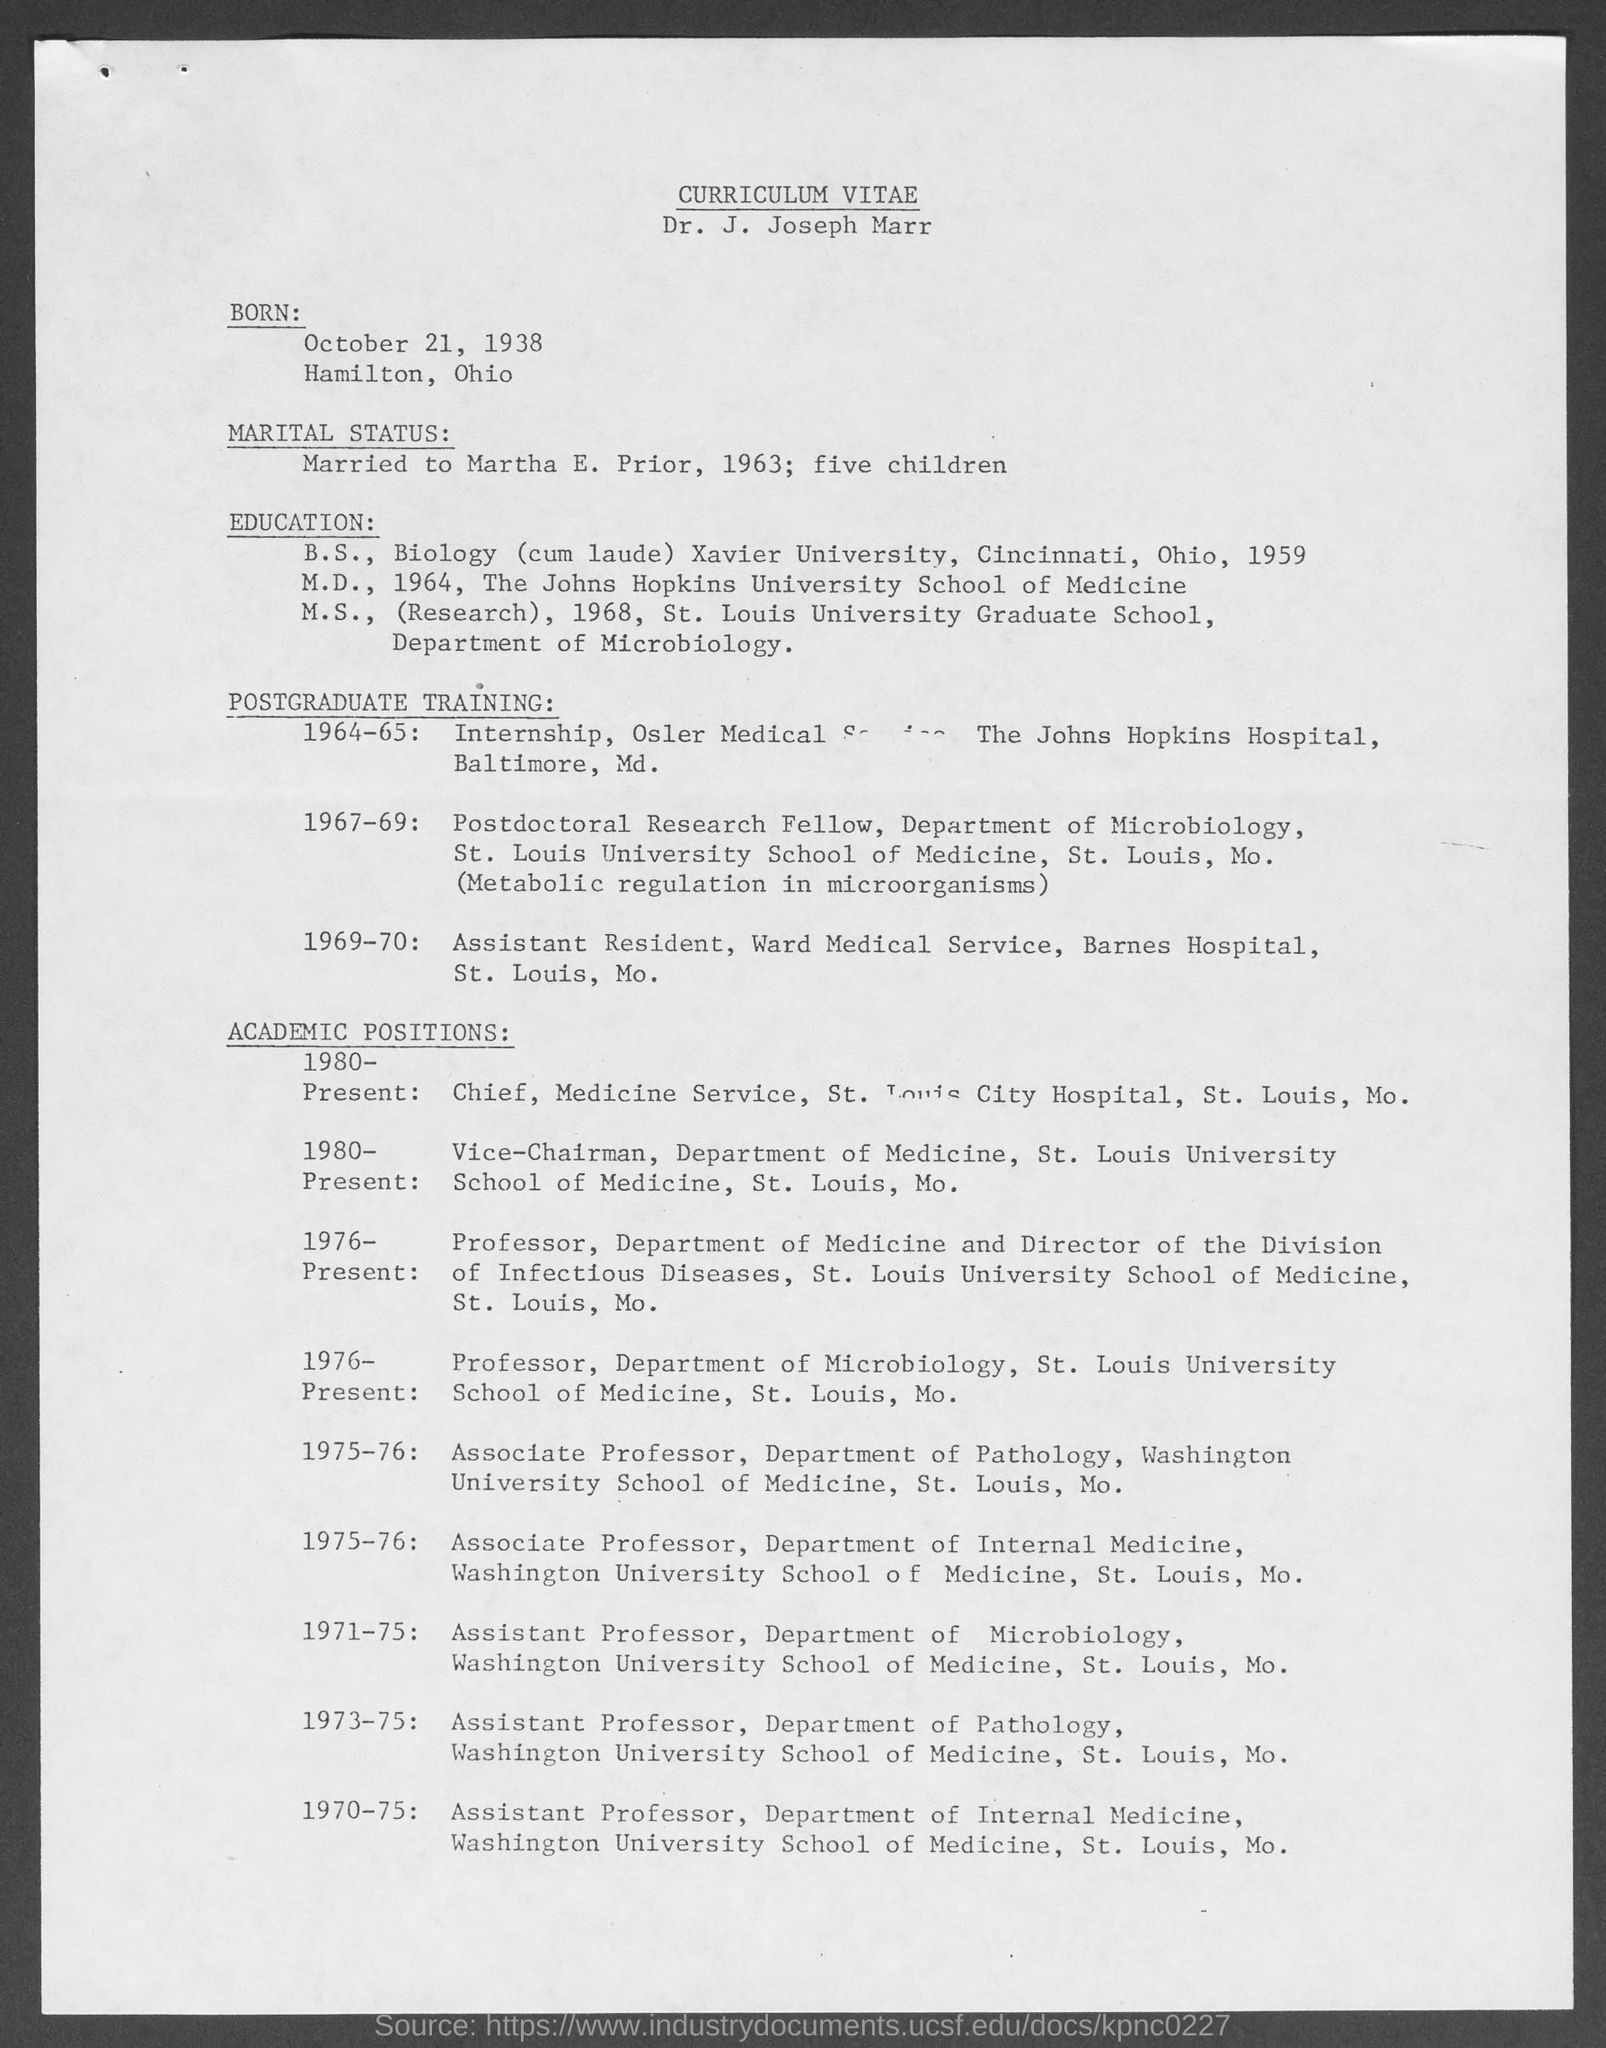List a handful of essential elements in this visual. Dr. J. Joseph Marr completed his M.S. in 1968. The title at the top of the page is 'Curriculum Vitae.' In 1964, Dr. J. Joseph Marr completed his M.D. In 1959, Dr. J. Joseph Marr completed his B.S. 